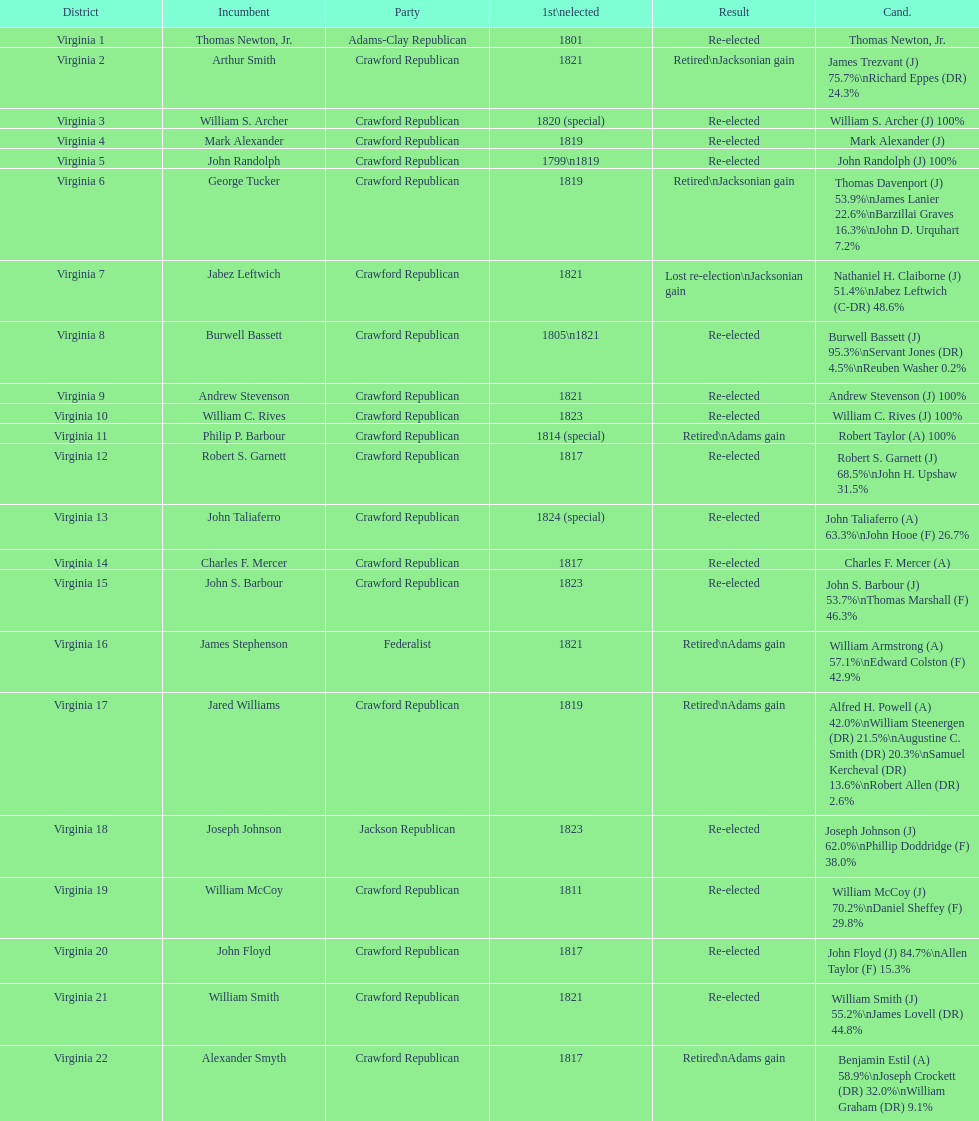Number of incumbents who retired or lost re-election 7. 